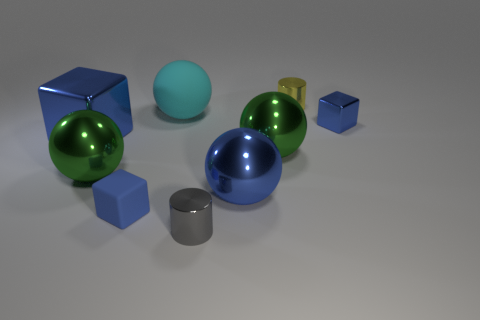There is a ball that is the same color as the small rubber cube; what is its size?
Your response must be concise. Large. There is a small cube in front of the big blue block; is its color the same as the shiny object right of the yellow thing?
Keep it short and to the point. Yes. What is the material of the big object that is the same color as the big metallic cube?
Offer a very short reply. Metal. Is the size of the rubber ball the same as the blue metallic ball?
Make the answer very short. Yes. What is the big cube made of?
Your response must be concise. Metal. What material is the gray cylinder that is the same size as the yellow object?
Provide a short and direct response. Metal. Are there any other metallic objects of the same size as the yellow shiny thing?
Keep it short and to the point. Yes. Is the number of big cyan spheres that are in front of the tiny matte thing the same as the number of small metal blocks that are to the left of the tiny gray thing?
Provide a succinct answer. Yes. Are there more small metal cubes than tiny cyan metallic spheres?
Keep it short and to the point. Yes. What number of shiny objects are tiny gray things or large balls?
Offer a terse response. 4. 